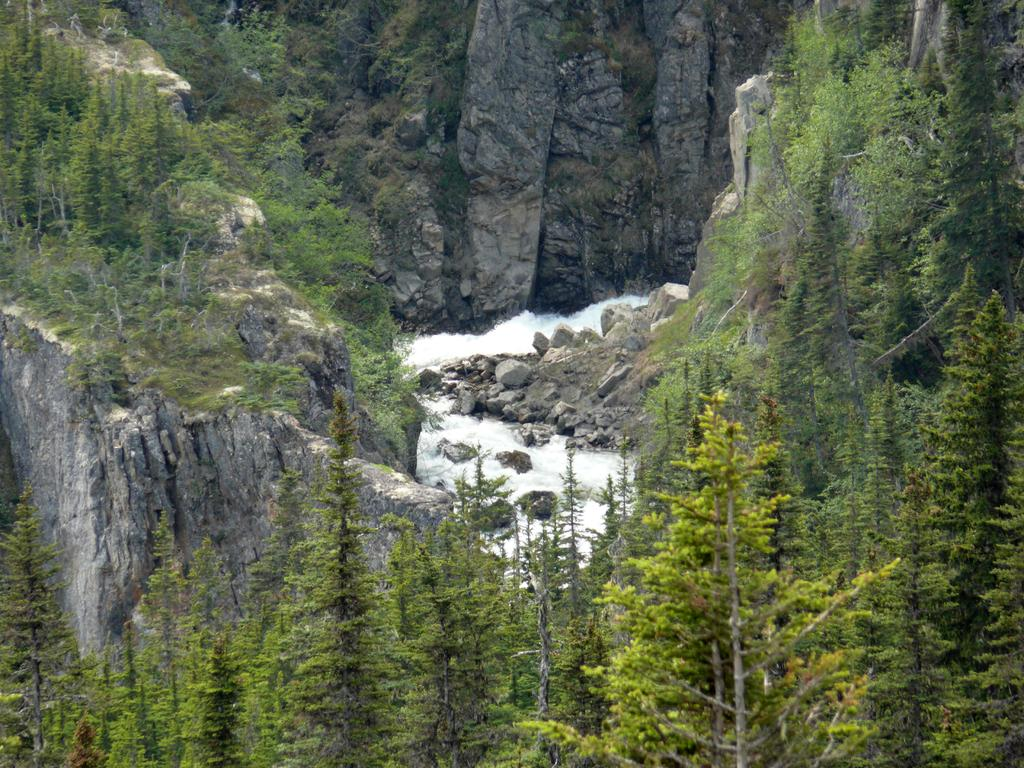What type of natural features can be seen in the image? There are trees and mountains in the image. What can be observed flowing in the image? There is a flow of water in the image. Where is the hall located in the image? There is no hall present in the image. Can you see a cow in the image? There is no cow present in the image. 